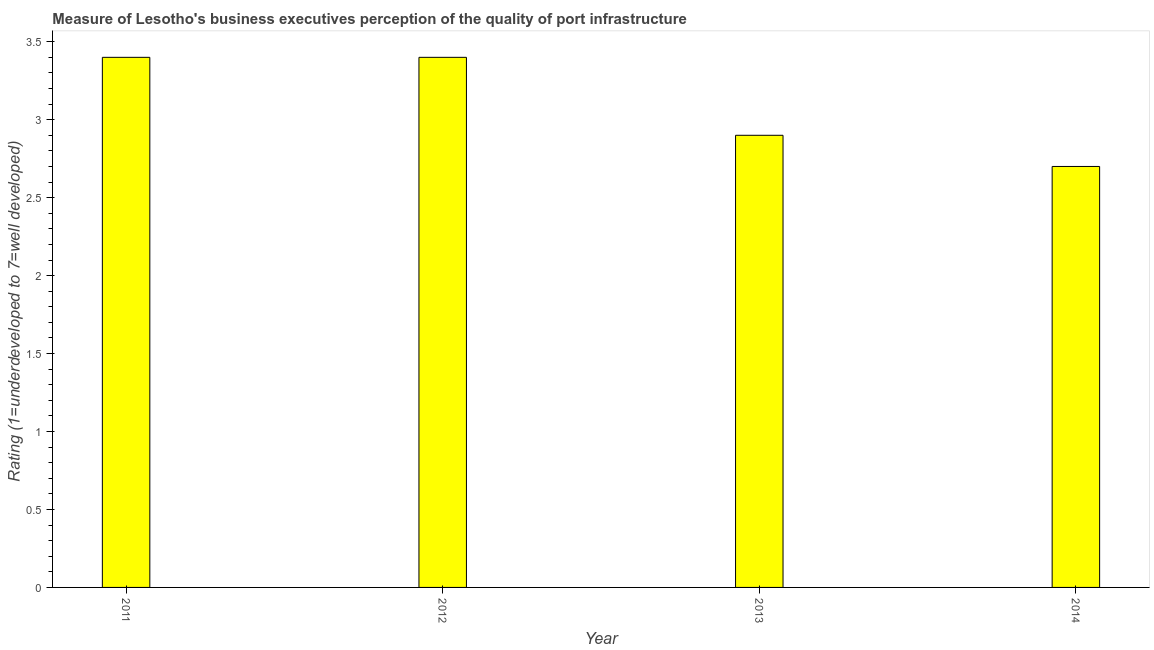Does the graph contain any zero values?
Your answer should be very brief. No. Does the graph contain grids?
Give a very brief answer. No. What is the title of the graph?
Provide a short and direct response. Measure of Lesotho's business executives perception of the quality of port infrastructure. What is the label or title of the X-axis?
Provide a succinct answer. Year. What is the label or title of the Y-axis?
Keep it short and to the point. Rating (1=underdeveloped to 7=well developed) . Across all years, what is the maximum rating measuring quality of port infrastructure?
Ensure brevity in your answer.  3.4. What is the sum of the rating measuring quality of port infrastructure?
Ensure brevity in your answer.  12.4. What is the average rating measuring quality of port infrastructure per year?
Give a very brief answer. 3.1. What is the median rating measuring quality of port infrastructure?
Offer a very short reply. 3.15. In how many years, is the rating measuring quality of port infrastructure greater than 0.7 ?
Make the answer very short. 4. What is the ratio of the rating measuring quality of port infrastructure in 2012 to that in 2013?
Provide a succinct answer. 1.17. Is the rating measuring quality of port infrastructure in 2012 less than that in 2013?
Make the answer very short. No. What is the difference between the highest and the second highest rating measuring quality of port infrastructure?
Give a very brief answer. 0. Is the sum of the rating measuring quality of port infrastructure in 2012 and 2013 greater than the maximum rating measuring quality of port infrastructure across all years?
Your answer should be compact. Yes. Are all the bars in the graph horizontal?
Your answer should be compact. No. What is the difference between two consecutive major ticks on the Y-axis?
Keep it short and to the point. 0.5. What is the Rating (1=underdeveloped to 7=well developed)  in 2011?
Your response must be concise. 3.4. What is the Rating (1=underdeveloped to 7=well developed)  of 2012?
Ensure brevity in your answer.  3.4. What is the Rating (1=underdeveloped to 7=well developed)  of 2014?
Offer a terse response. 2.7. What is the difference between the Rating (1=underdeveloped to 7=well developed)  in 2011 and 2012?
Keep it short and to the point. 0. What is the difference between the Rating (1=underdeveloped to 7=well developed)  in 2012 and 2013?
Keep it short and to the point. 0.5. What is the difference between the Rating (1=underdeveloped to 7=well developed)  in 2012 and 2014?
Provide a succinct answer. 0.7. What is the ratio of the Rating (1=underdeveloped to 7=well developed)  in 2011 to that in 2012?
Keep it short and to the point. 1. What is the ratio of the Rating (1=underdeveloped to 7=well developed)  in 2011 to that in 2013?
Offer a terse response. 1.17. What is the ratio of the Rating (1=underdeveloped to 7=well developed)  in 2011 to that in 2014?
Provide a short and direct response. 1.26. What is the ratio of the Rating (1=underdeveloped to 7=well developed)  in 2012 to that in 2013?
Give a very brief answer. 1.17. What is the ratio of the Rating (1=underdeveloped to 7=well developed)  in 2012 to that in 2014?
Ensure brevity in your answer.  1.26. What is the ratio of the Rating (1=underdeveloped to 7=well developed)  in 2013 to that in 2014?
Offer a very short reply. 1.07. 